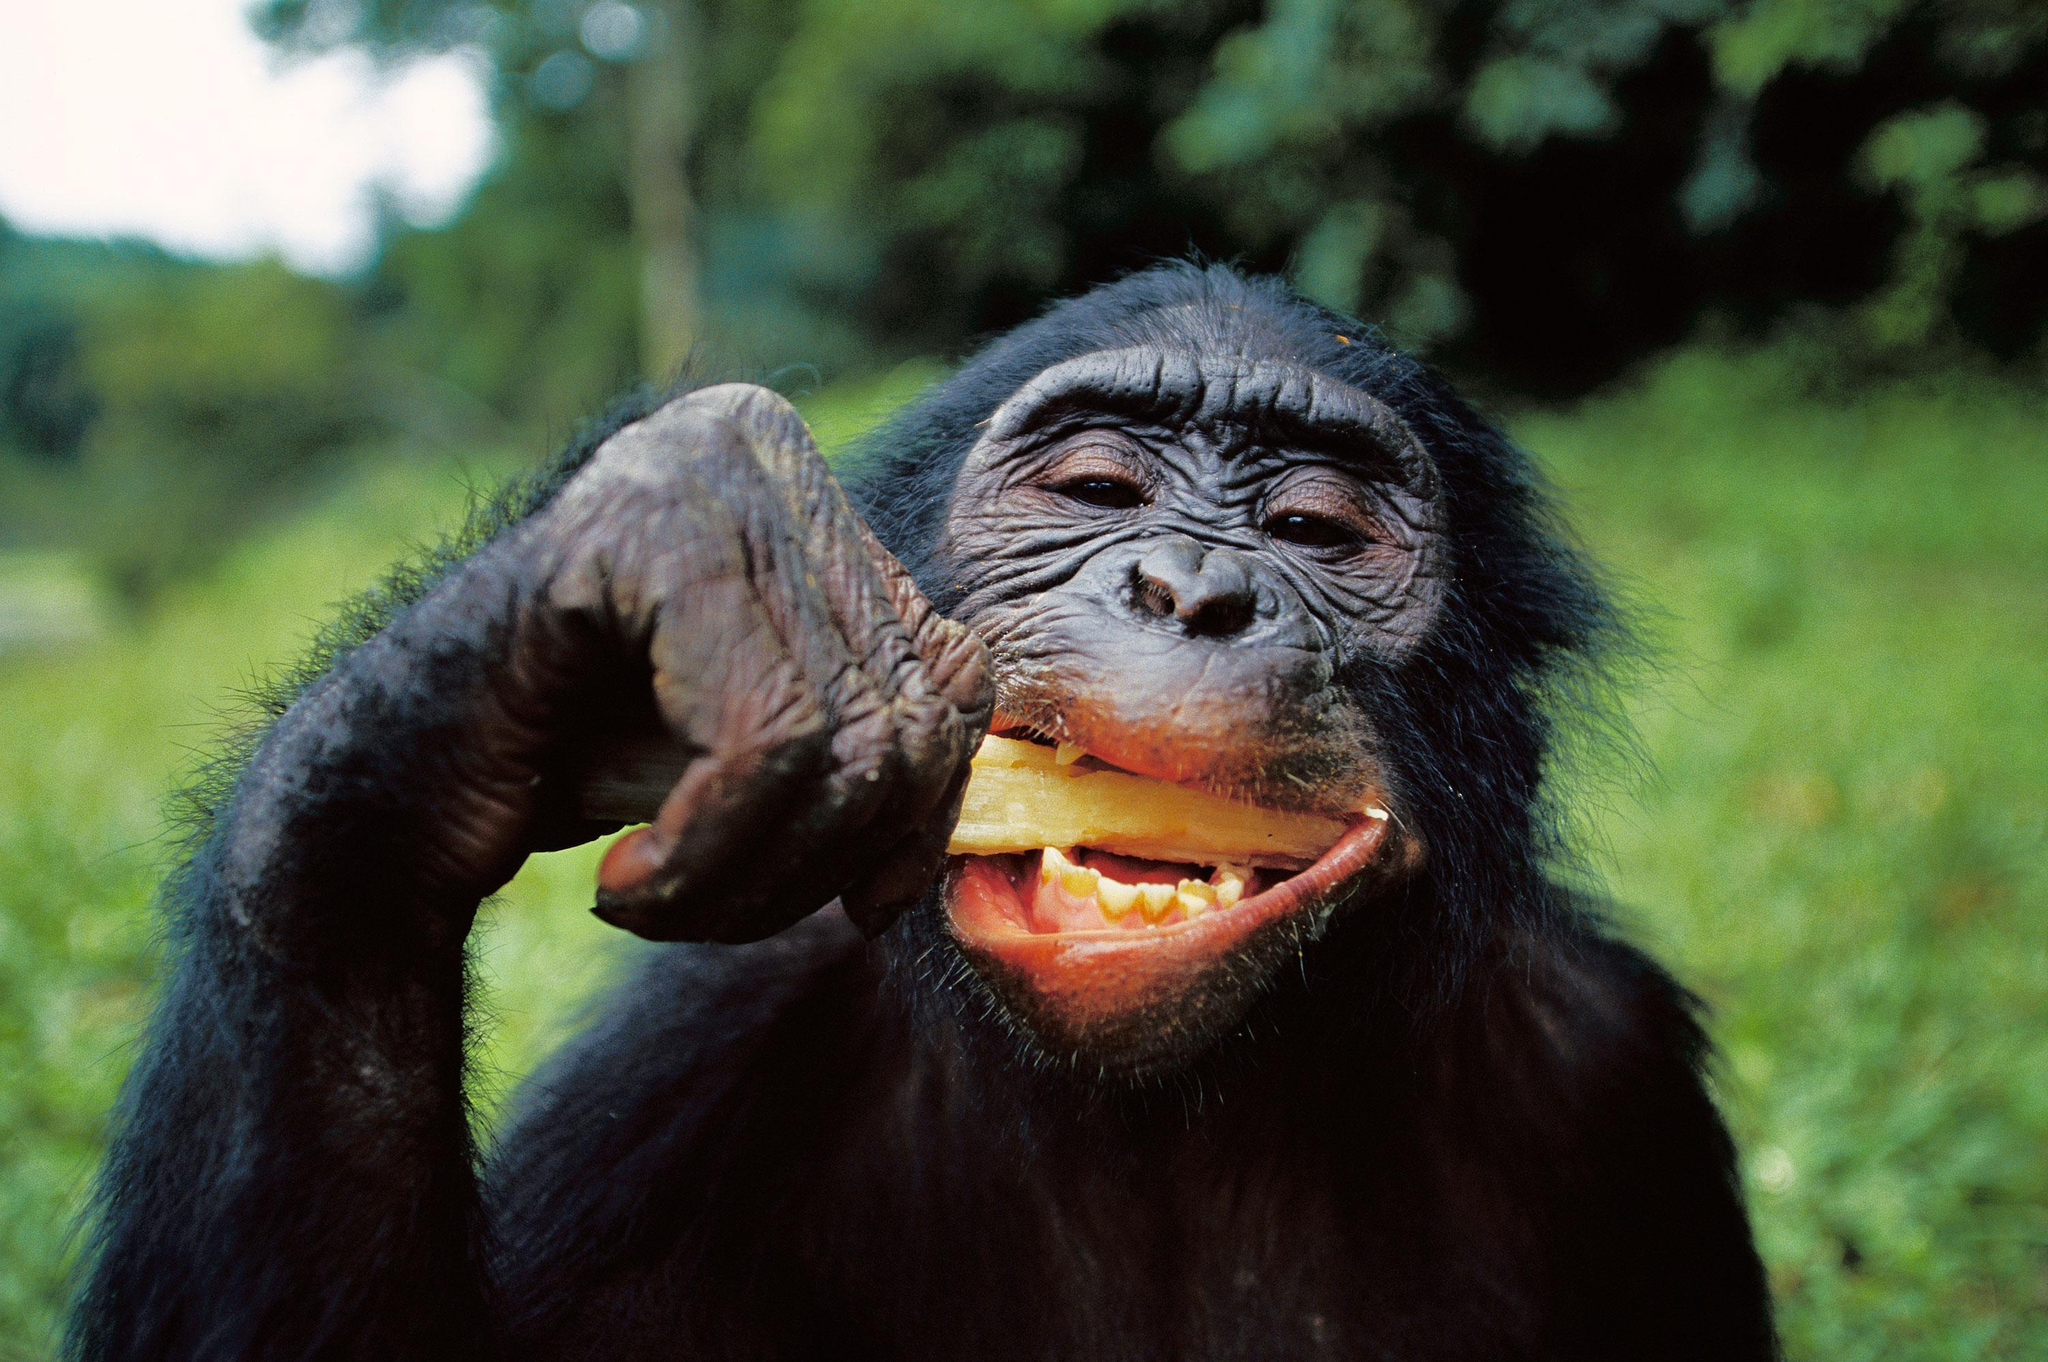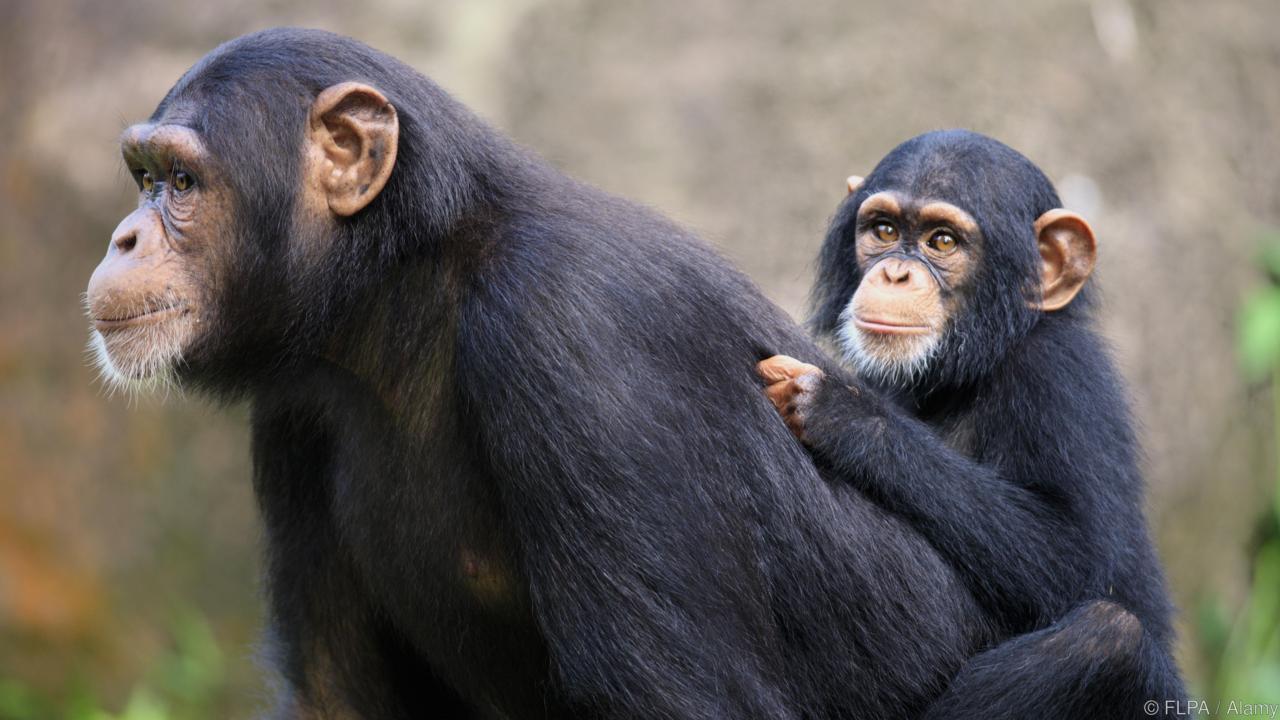The first image is the image on the left, the second image is the image on the right. Evaluate the accuracy of this statement regarding the images: "The monkey in one of the images is opening its mouth to reveal teeth.". Is it true? Answer yes or no. Yes. The first image is the image on the left, the second image is the image on the right. Considering the images on both sides, is "Each image shows one forward-facing young chimp with a light-colored face and ears that protrude." valid? Answer yes or no. No. 